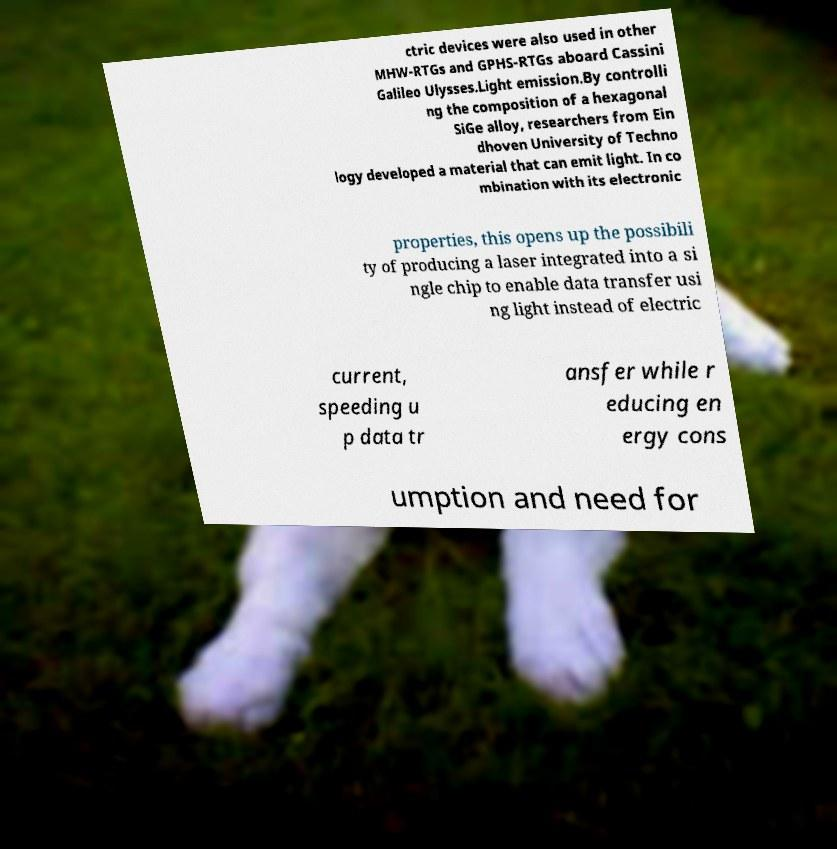Could you extract and type out the text from this image? ctric devices were also used in other MHW-RTGs and GPHS-RTGs aboard Cassini Galileo Ulysses.Light emission.By controlli ng the composition of a hexagonal SiGe alloy, researchers from Ein dhoven University of Techno logy developed a material that can emit light. In co mbination with its electronic properties, this opens up the possibili ty of producing a laser integrated into a si ngle chip to enable data transfer usi ng light instead of electric current, speeding u p data tr ansfer while r educing en ergy cons umption and need for 